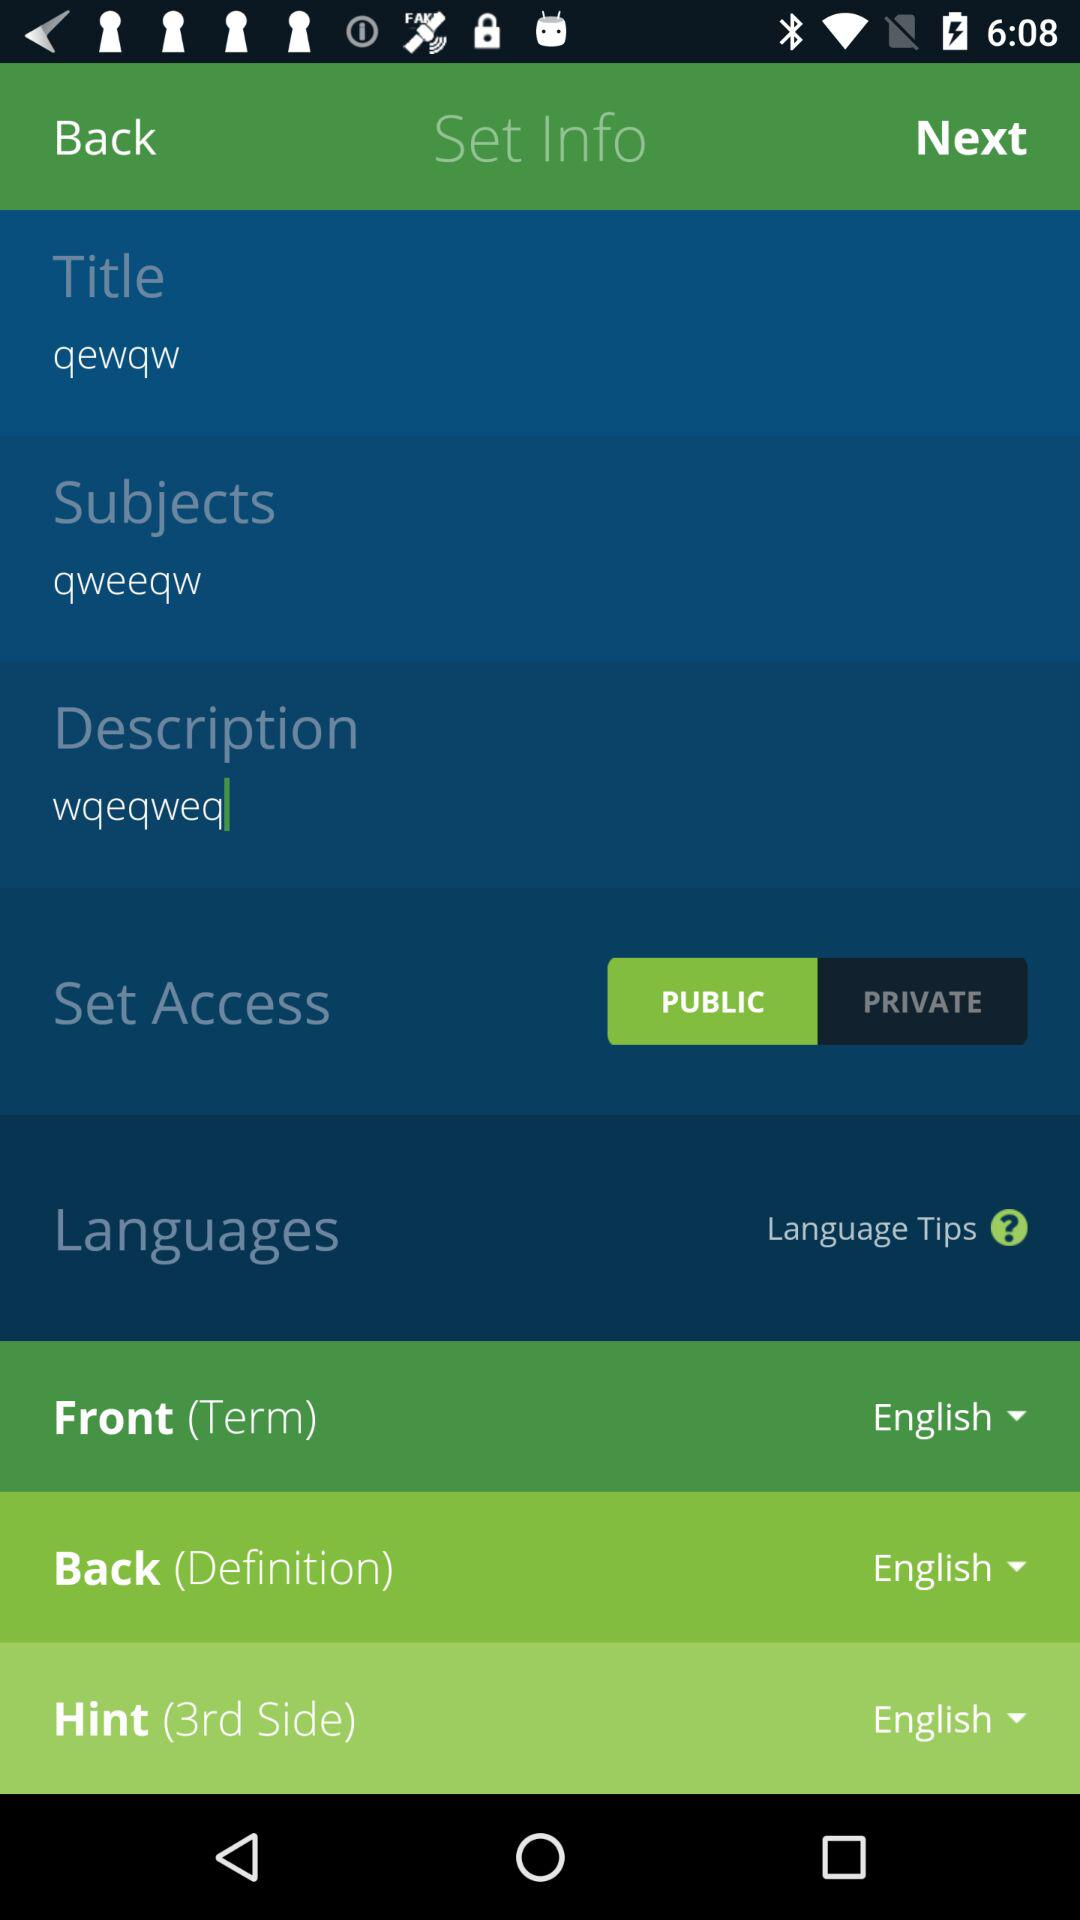What is the selected font?
When the provided information is insufficient, respond with <no answer>. <no answer> 